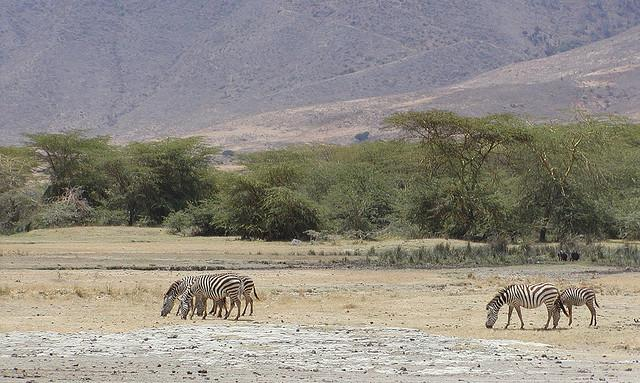What continent do these animals naturally live on?

Choices:
A) australia
B) europe
C) africa
D) north america australia 